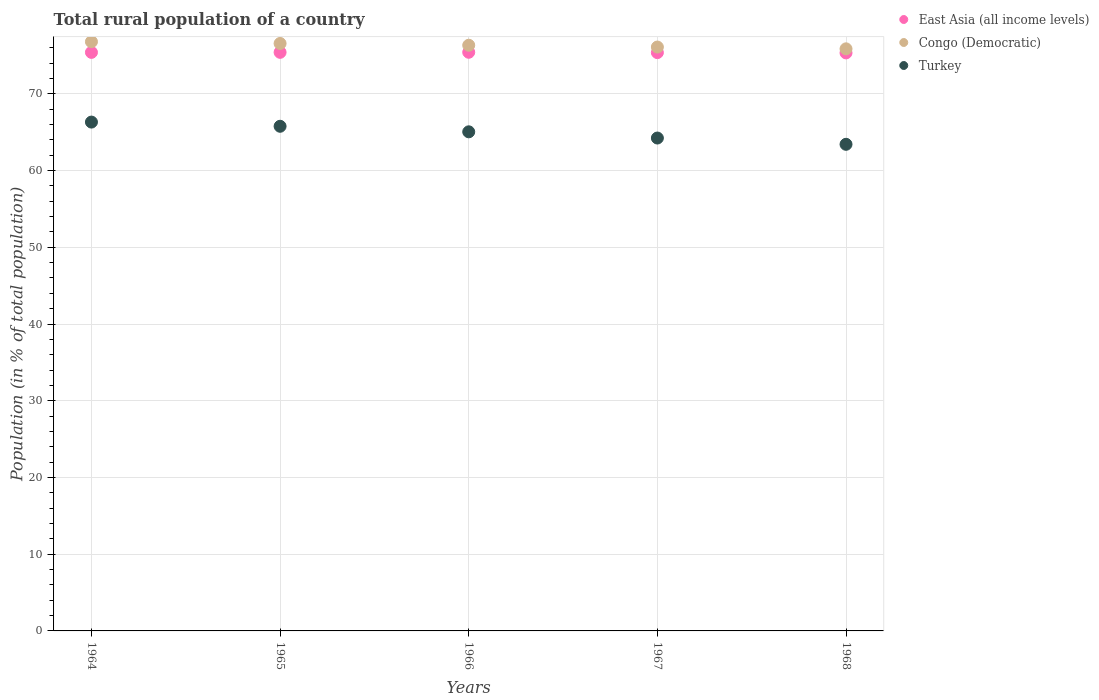How many different coloured dotlines are there?
Offer a terse response. 3. What is the rural population in East Asia (all income levels) in 1967?
Your answer should be compact. 75.37. Across all years, what is the maximum rural population in East Asia (all income levels)?
Keep it short and to the point. 75.42. Across all years, what is the minimum rural population in East Asia (all income levels)?
Your answer should be very brief. 75.34. In which year was the rural population in Turkey maximum?
Give a very brief answer. 1964. In which year was the rural population in Turkey minimum?
Offer a terse response. 1968. What is the total rural population in East Asia (all income levels) in the graph?
Your response must be concise. 376.94. What is the difference between the rural population in Congo (Democratic) in 1964 and that in 1968?
Offer a terse response. 0.93. What is the difference between the rural population in Turkey in 1968 and the rural population in East Asia (all income levels) in 1965?
Your response must be concise. -11.99. What is the average rural population in Turkey per year?
Your response must be concise. 64.96. In the year 1968, what is the difference between the rural population in Turkey and rural population in Congo (Democratic)?
Make the answer very short. -12.44. In how many years, is the rural population in East Asia (all income levels) greater than 68 %?
Your response must be concise. 5. What is the ratio of the rural population in Congo (Democratic) in 1965 to that in 1966?
Make the answer very short. 1. Is the difference between the rural population in Turkey in 1965 and 1966 greater than the difference between the rural population in Congo (Democratic) in 1965 and 1966?
Your response must be concise. Yes. What is the difference between the highest and the second highest rural population in Turkey?
Keep it short and to the point. 0.55. What is the difference between the highest and the lowest rural population in East Asia (all income levels)?
Give a very brief answer. 0.08. Is the rural population in Congo (Democratic) strictly greater than the rural population in Turkey over the years?
Offer a very short reply. Yes. Is the rural population in Congo (Democratic) strictly less than the rural population in Turkey over the years?
Give a very brief answer. No. What is the difference between two consecutive major ticks on the Y-axis?
Offer a very short reply. 10. Are the values on the major ticks of Y-axis written in scientific E-notation?
Provide a short and direct response. No. Does the graph contain any zero values?
Offer a very short reply. No. Where does the legend appear in the graph?
Offer a terse response. Top right. How are the legend labels stacked?
Ensure brevity in your answer.  Vertical. What is the title of the graph?
Provide a short and direct response. Total rural population of a country. What is the label or title of the Y-axis?
Your answer should be compact. Population (in % of total population). What is the Population (in % of total population) of East Asia (all income levels) in 1964?
Your answer should be compact. 75.4. What is the Population (in % of total population) in Congo (Democratic) in 1964?
Provide a succinct answer. 76.8. What is the Population (in % of total population) of Turkey in 1964?
Provide a succinct answer. 66.32. What is the Population (in % of total population) of East Asia (all income levels) in 1965?
Your answer should be very brief. 75.41. What is the Population (in % of total population) in Congo (Democratic) in 1965?
Make the answer very short. 76.57. What is the Population (in % of total population) in Turkey in 1965?
Offer a very short reply. 65.77. What is the Population (in % of total population) of East Asia (all income levels) in 1966?
Your answer should be compact. 75.42. What is the Population (in % of total population) of Congo (Democratic) in 1966?
Ensure brevity in your answer.  76.33. What is the Population (in % of total population) of Turkey in 1966?
Offer a very short reply. 65.05. What is the Population (in % of total population) in East Asia (all income levels) in 1967?
Your response must be concise. 75.37. What is the Population (in % of total population) in Congo (Democratic) in 1967?
Offer a terse response. 76.1. What is the Population (in % of total population) of Turkey in 1967?
Provide a short and direct response. 64.24. What is the Population (in % of total population) of East Asia (all income levels) in 1968?
Keep it short and to the point. 75.34. What is the Population (in % of total population) of Congo (Democratic) in 1968?
Keep it short and to the point. 75.87. What is the Population (in % of total population) of Turkey in 1968?
Provide a succinct answer. 63.42. Across all years, what is the maximum Population (in % of total population) in East Asia (all income levels)?
Ensure brevity in your answer.  75.42. Across all years, what is the maximum Population (in % of total population) in Congo (Democratic)?
Your response must be concise. 76.8. Across all years, what is the maximum Population (in % of total population) of Turkey?
Provide a succinct answer. 66.32. Across all years, what is the minimum Population (in % of total population) of East Asia (all income levels)?
Give a very brief answer. 75.34. Across all years, what is the minimum Population (in % of total population) of Congo (Democratic)?
Your answer should be compact. 75.87. Across all years, what is the minimum Population (in % of total population) in Turkey?
Keep it short and to the point. 63.42. What is the total Population (in % of total population) of East Asia (all income levels) in the graph?
Offer a terse response. 376.94. What is the total Population (in % of total population) in Congo (Democratic) in the graph?
Provide a succinct answer. 381.66. What is the total Population (in % of total population) of Turkey in the graph?
Ensure brevity in your answer.  324.81. What is the difference between the Population (in % of total population) in East Asia (all income levels) in 1964 and that in 1965?
Offer a terse response. -0.01. What is the difference between the Population (in % of total population) in Congo (Democratic) in 1964 and that in 1965?
Provide a short and direct response. 0.23. What is the difference between the Population (in % of total population) in Turkey in 1964 and that in 1965?
Keep it short and to the point. 0.55. What is the difference between the Population (in % of total population) in East Asia (all income levels) in 1964 and that in 1966?
Provide a short and direct response. -0.01. What is the difference between the Population (in % of total population) in Congo (Democratic) in 1964 and that in 1966?
Keep it short and to the point. 0.46. What is the difference between the Population (in % of total population) in Turkey in 1964 and that in 1966?
Your response must be concise. 1.27. What is the difference between the Population (in % of total population) of East Asia (all income levels) in 1964 and that in 1967?
Provide a short and direct response. 0.03. What is the difference between the Population (in % of total population) in Congo (Democratic) in 1964 and that in 1967?
Keep it short and to the point. 0.69. What is the difference between the Population (in % of total population) in Turkey in 1964 and that in 1967?
Provide a succinct answer. 2.08. What is the difference between the Population (in % of total population) of East Asia (all income levels) in 1964 and that in 1968?
Give a very brief answer. 0.07. What is the difference between the Population (in % of total population) of Congo (Democratic) in 1964 and that in 1968?
Your answer should be compact. 0.93. What is the difference between the Population (in % of total population) in Turkey in 1964 and that in 1968?
Your response must be concise. 2.9. What is the difference between the Population (in % of total population) of East Asia (all income levels) in 1965 and that in 1966?
Your response must be concise. -0.01. What is the difference between the Population (in % of total population) of Congo (Democratic) in 1965 and that in 1966?
Your answer should be very brief. 0.23. What is the difference between the Population (in % of total population) in Turkey in 1965 and that in 1966?
Ensure brevity in your answer.  0.72. What is the difference between the Population (in % of total population) in East Asia (all income levels) in 1965 and that in 1967?
Offer a very short reply. 0.04. What is the difference between the Population (in % of total population) of Congo (Democratic) in 1965 and that in 1967?
Give a very brief answer. 0.47. What is the difference between the Population (in % of total population) in Turkey in 1965 and that in 1967?
Offer a terse response. 1.53. What is the difference between the Population (in % of total population) in East Asia (all income levels) in 1965 and that in 1968?
Keep it short and to the point. 0.07. What is the difference between the Population (in % of total population) of Turkey in 1965 and that in 1968?
Keep it short and to the point. 2.35. What is the difference between the Population (in % of total population) in East Asia (all income levels) in 1966 and that in 1967?
Your answer should be compact. 0.04. What is the difference between the Population (in % of total population) in Congo (Democratic) in 1966 and that in 1967?
Your answer should be very brief. 0.23. What is the difference between the Population (in % of total population) of Turkey in 1966 and that in 1967?
Offer a terse response. 0.81. What is the difference between the Population (in % of total population) of East Asia (all income levels) in 1966 and that in 1968?
Your answer should be compact. 0.08. What is the difference between the Population (in % of total population) of Congo (Democratic) in 1966 and that in 1968?
Your answer should be very brief. 0.47. What is the difference between the Population (in % of total population) in Turkey in 1966 and that in 1968?
Provide a short and direct response. 1.63. What is the difference between the Population (in % of total population) in East Asia (all income levels) in 1967 and that in 1968?
Provide a succinct answer. 0.04. What is the difference between the Population (in % of total population) of Congo (Democratic) in 1967 and that in 1968?
Offer a terse response. 0.23. What is the difference between the Population (in % of total population) in Turkey in 1967 and that in 1968?
Keep it short and to the point. 0.82. What is the difference between the Population (in % of total population) of East Asia (all income levels) in 1964 and the Population (in % of total population) of Congo (Democratic) in 1965?
Offer a very short reply. -1.16. What is the difference between the Population (in % of total population) in East Asia (all income levels) in 1964 and the Population (in % of total population) in Turkey in 1965?
Offer a terse response. 9.63. What is the difference between the Population (in % of total population) of Congo (Democratic) in 1964 and the Population (in % of total population) of Turkey in 1965?
Provide a succinct answer. 11.02. What is the difference between the Population (in % of total population) of East Asia (all income levels) in 1964 and the Population (in % of total population) of Congo (Democratic) in 1966?
Give a very brief answer. -0.93. What is the difference between the Population (in % of total population) of East Asia (all income levels) in 1964 and the Population (in % of total population) of Turkey in 1966?
Offer a very short reply. 10.35. What is the difference between the Population (in % of total population) of Congo (Democratic) in 1964 and the Population (in % of total population) of Turkey in 1966?
Ensure brevity in your answer.  11.74. What is the difference between the Population (in % of total population) in East Asia (all income levels) in 1964 and the Population (in % of total population) in Congo (Democratic) in 1967?
Offer a very short reply. -0.7. What is the difference between the Population (in % of total population) in East Asia (all income levels) in 1964 and the Population (in % of total population) in Turkey in 1967?
Offer a very short reply. 11.16. What is the difference between the Population (in % of total population) of Congo (Democratic) in 1964 and the Population (in % of total population) of Turkey in 1967?
Keep it short and to the point. 12.55. What is the difference between the Population (in % of total population) in East Asia (all income levels) in 1964 and the Population (in % of total population) in Congo (Democratic) in 1968?
Ensure brevity in your answer.  -0.46. What is the difference between the Population (in % of total population) of East Asia (all income levels) in 1964 and the Population (in % of total population) of Turkey in 1968?
Offer a very short reply. 11.98. What is the difference between the Population (in % of total population) of Congo (Democratic) in 1964 and the Population (in % of total population) of Turkey in 1968?
Make the answer very short. 13.37. What is the difference between the Population (in % of total population) in East Asia (all income levels) in 1965 and the Population (in % of total population) in Congo (Democratic) in 1966?
Your answer should be compact. -0.92. What is the difference between the Population (in % of total population) in East Asia (all income levels) in 1965 and the Population (in % of total population) in Turkey in 1966?
Keep it short and to the point. 10.36. What is the difference between the Population (in % of total population) of Congo (Democratic) in 1965 and the Population (in % of total population) of Turkey in 1966?
Provide a short and direct response. 11.52. What is the difference between the Population (in % of total population) of East Asia (all income levels) in 1965 and the Population (in % of total population) of Congo (Democratic) in 1967?
Provide a short and direct response. -0.69. What is the difference between the Population (in % of total population) in East Asia (all income levels) in 1965 and the Population (in % of total population) in Turkey in 1967?
Make the answer very short. 11.17. What is the difference between the Population (in % of total population) of Congo (Democratic) in 1965 and the Population (in % of total population) of Turkey in 1967?
Ensure brevity in your answer.  12.32. What is the difference between the Population (in % of total population) in East Asia (all income levels) in 1965 and the Population (in % of total population) in Congo (Democratic) in 1968?
Keep it short and to the point. -0.46. What is the difference between the Population (in % of total population) in East Asia (all income levels) in 1965 and the Population (in % of total population) in Turkey in 1968?
Offer a very short reply. 11.99. What is the difference between the Population (in % of total population) of Congo (Democratic) in 1965 and the Population (in % of total population) of Turkey in 1968?
Make the answer very short. 13.14. What is the difference between the Population (in % of total population) of East Asia (all income levels) in 1966 and the Population (in % of total population) of Congo (Democratic) in 1967?
Your answer should be compact. -0.68. What is the difference between the Population (in % of total population) in East Asia (all income levels) in 1966 and the Population (in % of total population) in Turkey in 1967?
Offer a terse response. 11.18. What is the difference between the Population (in % of total population) of Congo (Democratic) in 1966 and the Population (in % of total population) of Turkey in 1967?
Provide a succinct answer. 12.09. What is the difference between the Population (in % of total population) in East Asia (all income levels) in 1966 and the Population (in % of total population) in Congo (Democratic) in 1968?
Give a very brief answer. -0.45. What is the difference between the Population (in % of total population) of East Asia (all income levels) in 1966 and the Population (in % of total population) of Turkey in 1968?
Give a very brief answer. 11.99. What is the difference between the Population (in % of total population) in Congo (Democratic) in 1966 and the Population (in % of total population) in Turkey in 1968?
Your response must be concise. 12.91. What is the difference between the Population (in % of total population) of East Asia (all income levels) in 1967 and the Population (in % of total population) of Congo (Democratic) in 1968?
Keep it short and to the point. -0.49. What is the difference between the Population (in % of total population) in East Asia (all income levels) in 1967 and the Population (in % of total population) in Turkey in 1968?
Make the answer very short. 11.95. What is the difference between the Population (in % of total population) of Congo (Democratic) in 1967 and the Population (in % of total population) of Turkey in 1968?
Provide a succinct answer. 12.68. What is the average Population (in % of total population) of East Asia (all income levels) per year?
Your response must be concise. 75.39. What is the average Population (in % of total population) of Congo (Democratic) per year?
Your answer should be very brief. 76.33. What is the average Population (in % of total population) in Turkey per year?
Your answer should be very brief. 64.96. In the year 1964, what is the difference between the Population (in % of total population) in East Asia (all income levels) and Population (in % of total population) in Congo (Democratic)?
Your answer should be very brief. -1.39. In the year 1964, what is the difference between the Population (in % of total population) of East Asia (all income levels) and Population (in % of total population) of Turkey?
Give a very brief answer. 9.08. In the year 1964, what is the difference between the Population (in % of total population) of Congo (Democratic) and Population (in % of total population) of Turkey?
Offer a terse response. 10.48. In the year 1965, what is the difference between the Population (in % of total population) in East Asia (all income levels) and Population (in % of total population) in Congo (Democratic)?
Make the answer very short. -1.16. In the year 1965, what is the difference between the Population (in % of total population) of East Asia (all income levels) and Population (in % of total population) of Turkey?
Offer a very short reply. 9.64. In the year 1965, what is the difference between the Population (in % of total population) in Congo (Democratic) and Population (in % of total population) in Turkey?
Give a very brief answer. 10.79. In the year 1966, what is the difference between the Population (in % of total population) of East Asia (all income levels) and Population (in % of total population) of Congo (Democratic)?
Provide a succinct answer. -0.92. In the year 1966, what is the difference between the Population (in % of total population) in East Asia (all income levels) and Population (in % of total population) in Turkey?
Provide a short and direct response. 10.37. In the year 1966, what is the difference between the Population (in % of total population) in Congo (Democratic) and Population (in % of total population) in Turkey?
Offer a terse response. 11.28. In the year 1967, what is the difference between the Population (in % of total population) in East Asia (all income levels) and Population (in % of total population) in Congo (Democratic)?
Ensure brevity in your answer.  -0.73. In the year 1967, what is the difference between the Population (in % of total population) in East Asia (all income levels) and Population (in % of total population) in Turkey?
Provide a succinct answer. 11.13. In the year 1967, what is the difference between the Population (in % of total population) in Congo (Democratic) and Population (in % of total population) in Turkey?
Provide a succinct answer. 11.86. In the year 1968, what is the difference between the Population (in % of total population) in East Asia (all income levels) and Population (in % of total population) in Congo (Democratic)?
Offer a terse response. -0.53. In the year 1968, what is the difference between the Population (in % of total population) in East Asia (all income levels) and Population (in % of total population) in Turkey?
Your response must be concise. 11.91. In the year 1968, what is the difference between the Population (in % of total population) of Congo (Democratic) and Population (in % of total population) of Turkey?
Provide a succinct answer. 12.44. What is the ratio of the Population (in % of total population) in East Asia (all income levels) in 1964 to that in 1965?
Offer a terse response. 1. What is the ratio of the Population (in % of total population) in Congo (Democratic) in 1964 to that in 1965?
Your response must be concise. 1. What is the ratio of the Population (in % of total population) in Turkey in 1964 to that in 1965?
Give a very brief answer. 1.01. What is the ratio of the Population (in % of total population) of East Asia (all income levels) in 1964 to that in 1966?
Offer a very short reply. 1. What is the ratio of the Population (in % of total population) in Congo (Democratic) in 1964 to that in 1966?
Provide a succinct answer. 1.01. What is the ratio of the Population (in % of total population) in Turkey in 1964 to that in 1966?
Provide a succinct answer. 1.02. What is the ratio of the Population (in % of total population) of Congo (Democratic) in 1964 to that in 1967?
Provide a succinct answer. 1.01. What is the ratio of the Population (in % of total population) in Turkey in 1964 to that in 1967?
Offer a very short reply. 1.03. What is the ratio of the Population (in % of total population) of Congo (Democratic) in 1964 to that in 1968?
Offer a very short reply. 1.01. What is the ratio of the Population (in % of total population) of Turkey in 1964 to that in 1968?
Your answer should be compact. 1.05. What is the ratio of the Population (in % of total population) in Turkey in 1965 to that in 1966?
Your answer should be compact. 1.01. What is the ratio of the Population (in % of total population) in East Asia (all income levels) in 1965 to that in 1967?
Offer a very short reply. 1. What is the ratio of the Population (in % of total population) in Congo (Democratic) in 1965 to that in 1967?
Your answer should be compact. 1.01. What is the ratio of the Population (in % of total population) of Turkey in 1965 to that in 1967?
Your response must be concise. 1.02. What is the ratio of the Population (in % of total population) in East Asia (all income levels) in 1965 to that in 1968?
Provide a short and direct response. 1. What is the ratio of the Population (in % of total population) of Congo (Democratic) in 1965 to that in 1968?
Provide a succinct answer. 1.01. What is the ratio of the Population (in % of total population) in Turkey in 1965 to that in 1968?
Make the answer very short. 1.04. What is the ratio of the Population (in % of total population) of Congo (Democratic) in 1966 to that in 1967?
Offer a terse response. 1. What is the ratio of the Population (in % of total population) in Turkey in 1966 to that in 1967?
Make the answer very short. 1.01. What is the ratio of the Population (in % of total population) in East Asia (all income levels) in 1966 to that in 1968?
Your answer should be very brief. 1. What is the ratio of the Population (in % of total population) in Congo (Democratic) in 1966 to that in 1968?
Your answer should be very brief. 1.01. What is the ratio of the Population (in % of total population) of Turkey in 1966 to that in 1968?
Ensure brevity in your answer.  1.03. What is the ratio of the Population (in % of total population) in East Asia (all income levels) in 1967 to that in 1968?
Ensure brevity in your answer.  1. What is the ratio of the Population (in % of total population) of Congo (Democratic) in 1967 to that in 1968?
Your response must be concise. 1. What is the ratio of the Population (in % of total population) in Turkey in 1967 to that in 1968?
Offer a terse response. 1.01. What is the difference between the highest and the second highest Population (in % of total population) of East Asia (all income levels)?
Your response must be concise. 0.01. What is the difference between the highest and the second highest Population (in % of total population) in Congo (Democratic)?
Give a very brief answer. 0.23. What is the difference between the highest and the second highest Population (in % of total population) in Turkey?
Your answer should be compact. 0.55. What is the difference between the highest and the lowest Population (in % of total population) of East Asia (all income levels)?
Your answer should be very brief. 0.08. What is the difference between the highest and the lowest Population (in % of total population) of Congo (Democratic)?
Make the answer very short. 0.93. What is the difference between the highest and the lowest Population (in % of total population) in Turkey?
Offer a terse response. 2.9. 